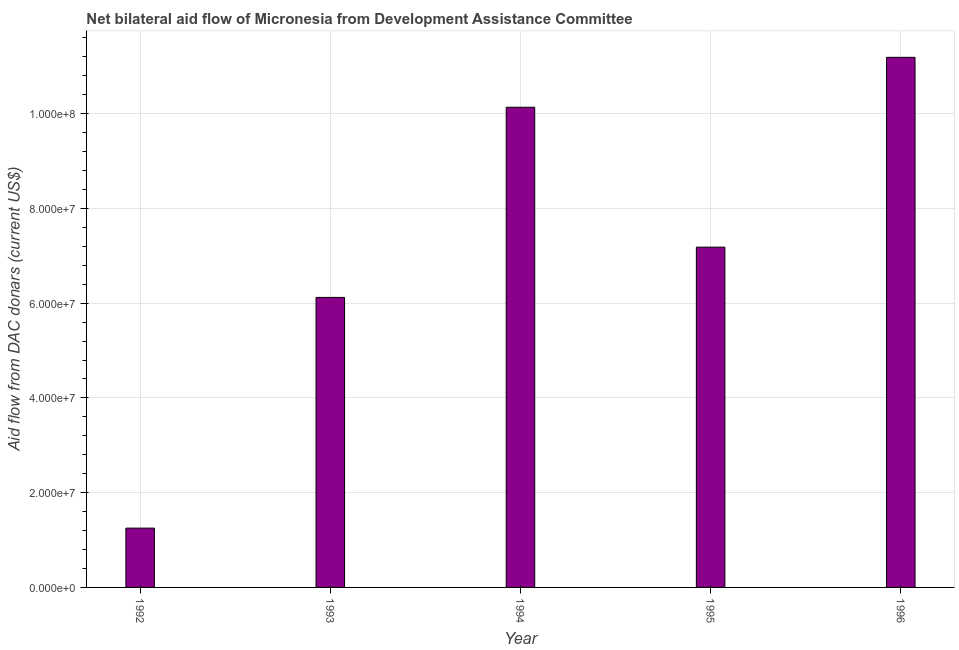What is the title of the graph?
Your answer should be very brief. Net bilateral aid flow of Micronesia from Development Assistance Committee. What is the label or title of the Y-axis?
Offer a terse response. Aid flow from DAC donars (current US$). What is the net bilateral aid flows from dac donors in 1992?
Your answer should be very brief. 1.25e+07. Across all years, what is the maximum net bilateral aid flows from dac donors?
Ensure brevity in your answer.  1.12e+08. Across all years, what is the minimum net bilateral aid flows from dac donors?
Keep it short and to the point. 1.25e+07. In which year was the net bilateral aid flows from dac donors maximum?
Provide a succinct answer. 1996. In which year was the net bilateral aid flows from dac donors minimum?
Provide a succinct answer. 1992. What is the sum of the net bilateral aid flows from dac donors?
Your answer should be very brief. 3.59e+08. What is the difference between the net bilateral aid flows from dac donors in 1992 and 1996?
Offer a terse response. -9.94e+07. What is the average net bilateral aid flows from dac donors per year?
Give a very brief answer. 7.18e+07. What is the median net bilateral aid flows from dac donors?
Give a very brief answer. 7.18e+07. In how many years, is the net bilateral aid flows from dac donors greater than 48000000 US$?
Keep it short and to the point. 4. Do a majority of the years between 1993 and 1994 (inclusive) have net bilateral aid flows from dac donors greater than 64000000 US$?
Your answer should be compact. No. What is the ratio of the net bilateral aid flows from dac donors in 1992 to that in 1993?
Ensure brevity in your answer.  0.2. Is the net bilateral aid flows from dac donors in 1994 less than that in 1995?
Make the answer very short. No. What is the difference between the highest and the second highest net bilateral aid flows from dac donors?
Keep it short and to the point. 1.05e+07. Is the sum of the net bilateral aid flows from dac donors in 1992 and 1996 greater than the maximum net bilateral aid flows from dac donors across all years?
Provide a short and direct response. Yes. What is the difference between the highest and the lowest net bilateral aid flows from dac donors?
Offer a terse response. 9.94e+07. In how many years, is the net bilateral aid flows from dac donors greater than the average net bilateral aid flows from dac donors taken over all years?
Provide a short and direct response. 3. What is the difference between two consecutive major ticks on the Y-axis?
Give a very brief answer. 2.00e+07. Are the values on the major ticks of Y-axis written in scientific E-notation?
Ensure brevity in your answer.  Yes. What is the Aid flow from DAC donars (current US$) in 1992?
Provide a succinct answer. 1.25e+07. What is the Aid flow from DAC donars (current US$) in 1993?
Provide a short and direct response. 6.12e+07. What is the Aid flow from DAC donars (current US$) of 1994?
Your response must be concise. 1.01e+08. What is the Aid flow from DAC donars (current US$) of 1995?
Your answer should be compact. 7.18e+07. What is the Aid flow from DAC donars (current US$) of 1996?
Your answer should be compact. 1.12e+08. What is the difference between the Aid flow from DAC donars (current US$) in 1992 and 1993?
Give a very brief answer. -4.87e+07. What is the difference between the Aid flow from DAC donars (current US$) in 1992 and 1994?
Provide a succinct answer. -8.88e+07. What is the difference between the Aid flow from DAC donars (current US$) in 1992 and 1995?
Ensure brevity in your answer.  -5.93e+07. What is the difference between the Aid flow from DAC donars (current US$) in 1992 and 1996?
Make the answer very short. -9.94e+07. What is the difference between the Aid flow from DAC donars (current US$) in 1993 and 1994?
Offer a very short reply. -4.01e+07. What is the difference between the Aid flow from DAC donars (current US$) in 1993 and 1995?
Your answer should be compact. -1.06e+07. What is the difference between the Aid flow from DAC donars (current US$) in 1993 and 1996?
Your response must be concise. -5.07e+07. What is the difference between the Aid flow from DAC donars (current US$) in 1994 and 1995?
Ensure brevity in your answer.  2.95e+07. What is the difference between the Aid flow from DAC donars (current US$) in 1994 and 1996?
Your answer should be compact. -1.05e+07. What is the difference between the Aid flow from DAC donars (current US$) in 1995 and 1996?
Your answer should be compact. -4.01e+07. What is the ratio of the Aid flow from DAC donars (current US$) in 1992 to that in 1993?
Give a very brief answer. 0.2. What is the ratio of the Aid flow from DAC donars (current US$) in 1992 to that in 1994?
Make the answer very short. 0.12. What is the ratio of the Aid flow from DAC donars (current US$) in 1992 to that in 1995?
Offer a terse response. 0.17. What is the ratio of the Aid flow from DAC donars (current US$) in 1992 to that in 1996?
Offer a very short reply. 0.11. What is the ratio of the Aid flow from DAC donars (current US$) in 1993 to that in 1994?
Provide a short and direct response. 0.6. What is the ratio of the Aid flow from DAC donars (current US$) in 1993 to that in 1995?
Your answer should be compact. 0.85. What is the ratio of the Aid flow from DAC donars (current US$) in 1993 to that in 1996?
Your response must be concise. 0.55. What is the ratio of the Aid flow from DAC donars (current US$) in 1994 to that in 1995?
Your answer should be very brief. 1.41. What is the ratio of the Aid flow from DAC donars (current US$) in 1994 to that in 1996?
Offer a very short reply. 0.91. What is the ratio of the Aid flow from DAC donars (current US$) in 1995 to that in 1996?
Your answer should be very brief. 0.64. 